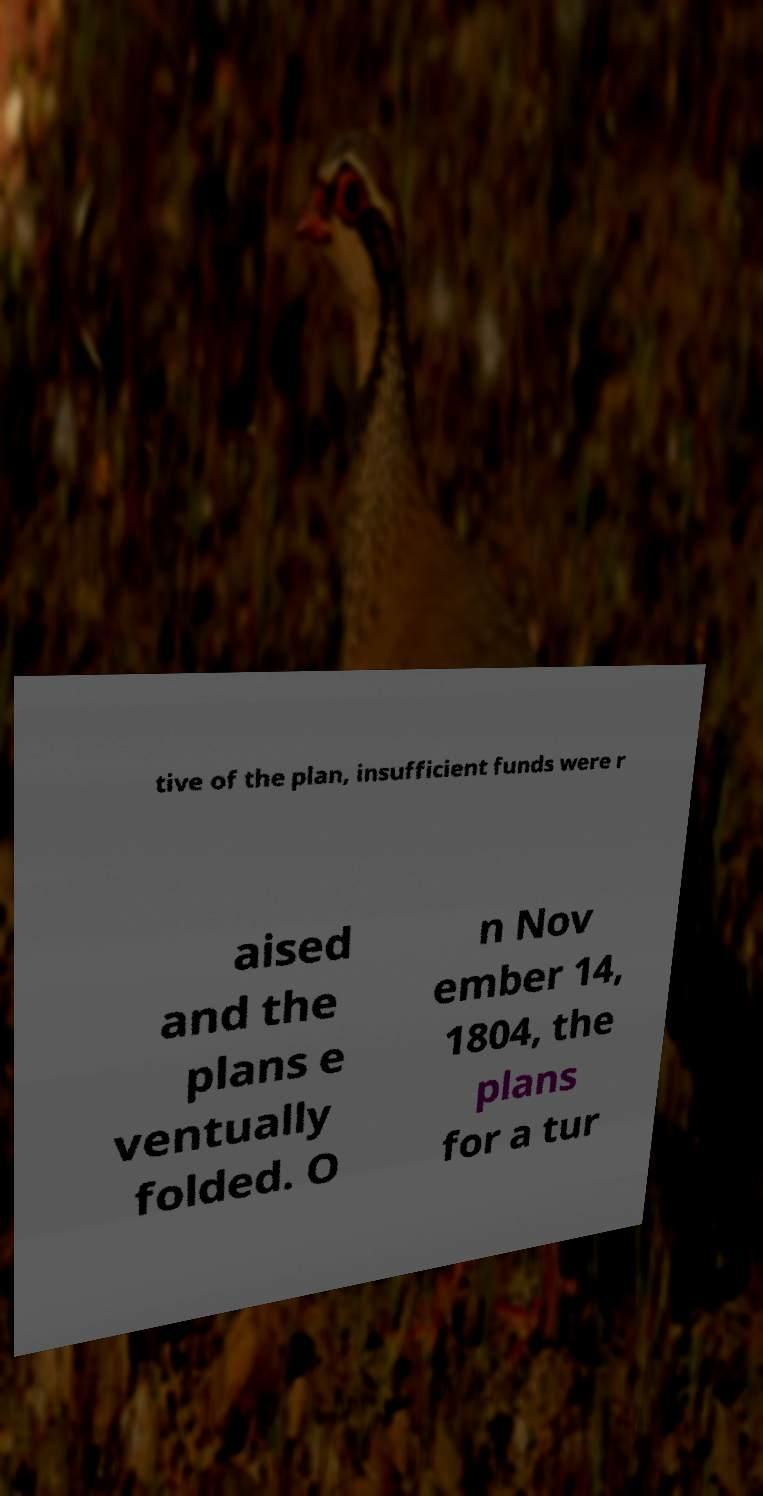Could you extract and type out the text from this image? tive of the plan, insufficient funds were r aised and the plans e ventually folded. O n Nov ember 14, 1804, the plans for a tur 